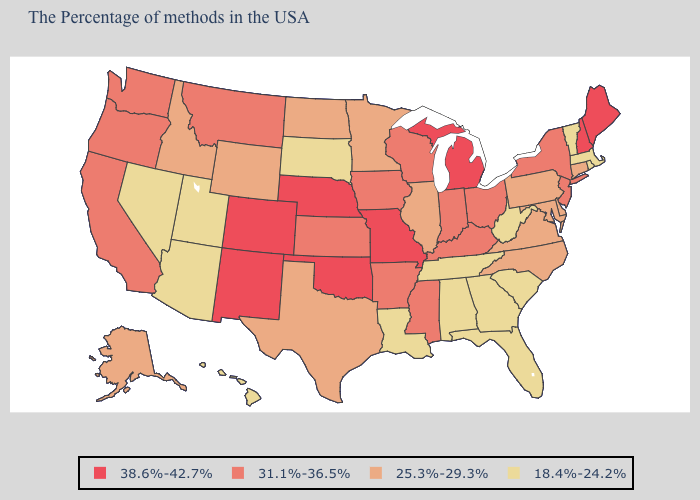Name the states that have a value in the range 25.3%-29.3%?
Be succinct. Connecticut, Delaware, Maryland, Pennsylvania, Virginia, North Carolina, Illinois, Minnesota, Texas, North Dakota, Wyoming, Idaho, Alaska. What is the lowest value in states that border South Carolina?
Write a very short answer. 18.4%-24.2%. What is the value of Ohio?
Give a very brief answer. 31.1%-36.5%. Name the states that have a value in the range 38.6%-42.7%?
Answer briefly. Maine, New Hampshire, Michigan, Missouri, Nebraska, Oklahoma, Colorado, New Mexico. Does Pennsylvania have a higher value than Wisconsin?
Be succinct. No. How many symbols are there in the legend?
Give a very brief answer. 4. Name the states that have a value in the range 38.6%-42.7%?
Short answer required. Maine, New Hampshire, Michigan, Missouri, Nebraska, Oklahoma, Colorado, New Mexico. Among the states that border Florida , which have the highest value?
Be succinct. Georgia, Alabama. What is the highest value in the Northeast ?
Short answer required. 38.6%-42.7%. What is the value of Mississippi?
Quick response, please. 31.1%-36.5%. Name the states that have a value in the range 38.6%-42.7%?
Write a very short answer. Maine, New Hampshire, Michigan, Missouri, Nebraska, Oklahoma, Colorado, New Mexico. What is the value of Massachusetts?
Short answer required. 18.4%-24.2%. Does Connecticut have a higher value than Arizona?
Keep it brief. Yes. What is the value of Pennsylvania?
Be succinct. 25.3%-29.3%. Name the states that have a value in the range 18.4%-24.2%?
Short answer required. Massachusetts, Rhode Island, Vermont, South Carolina, West Virginia, Florida, Georgia, Alabama, Tennessee, Louisiana, South Dakota, Utah, Arizona, Nevada, Hawaii. 